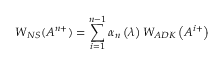Convert formula to latex. <formula><loc_0><loc_0><loc_500><loc_500>W _ { N S } ( A ^ { n + } ) = \sum _ { i = 1 } ^ { n - 1 } \alpha _ { n } \left ( \lambda \right ) W _ { A D K } \left ( A ^ { i + } \right )</formula> 